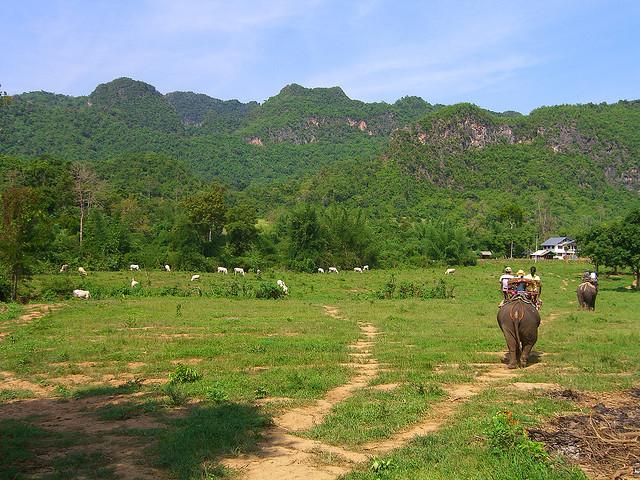Is the dog walking or sitting?
Give a very brief answer. Walking. What animals do you see?
Be succinct. Elephants. How many elephants are there?
Quick response, please. 2. What color is the dirt?
Answer briefly. Brown. What color is the roof of the house?
Keep it brief. Blue. Are there sheep in this picture?
Be succinct. Yes. How many goats are in the photo?
Short answer required. 0. What are these animals?
Write a very short answer. Elephants. Is there water present on the field?
Write a very short answer. No. 